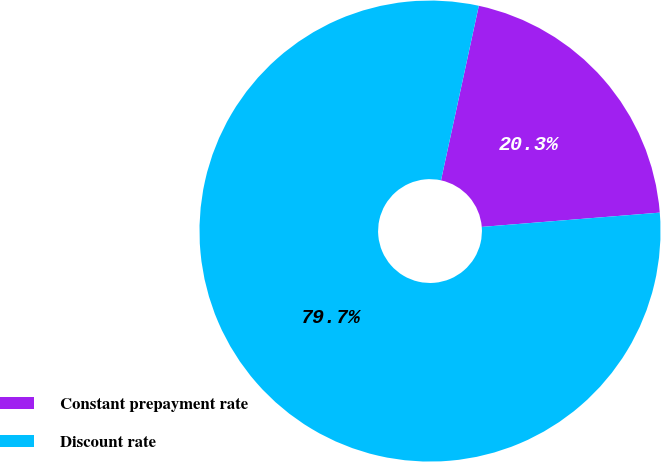Convert chart to OTSL. <chart><loc_0><loc_0><loc_500><loc_500><pie_chart><fcel>Constant prepayment rate<fcel>Discount rate<nl><fcel>20.33%<fcel>79.67%<nl></chart> 